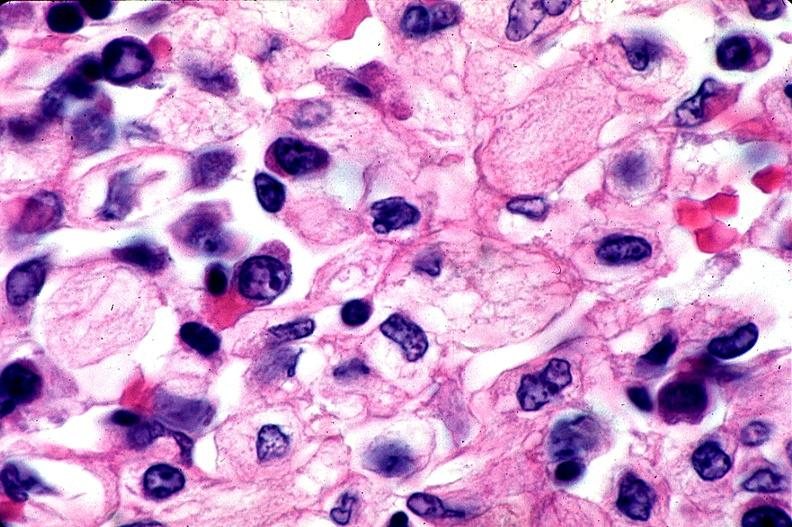s jejunum present?
Answer the question using a single word or phrase. No 